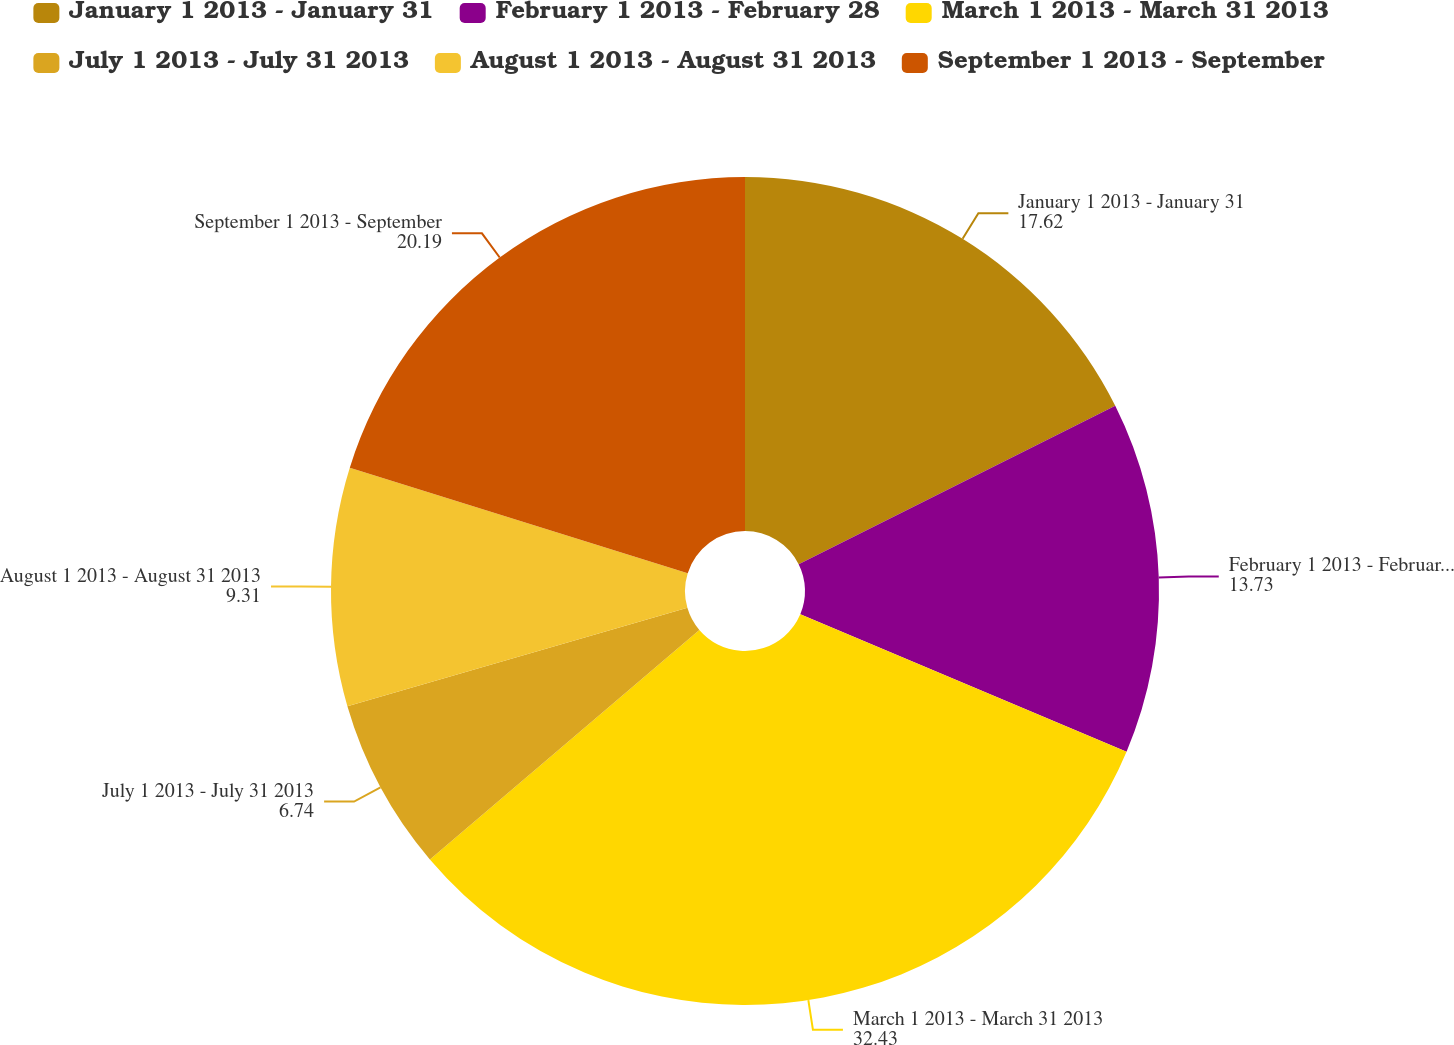Convert chart to OTSL. <chart><loc_0><loc_0><loc_500><loc_500><pie_chart><fcel>January 1 2013 - January 31<fcel>February 1 2013 - February 28<fcel>March 1 2013 - March 31 2013<fcel>July 1 2013 - July 31 2013<fcel>August 1 2013 - August 31 2013<fcel>September 1 2013 - September<nl><fcel>17.62%<fcel>13.73%<fcel>32.43%<fcel>6.74%<fcel>9.31%<fcel>20.19%<nl></chart> 